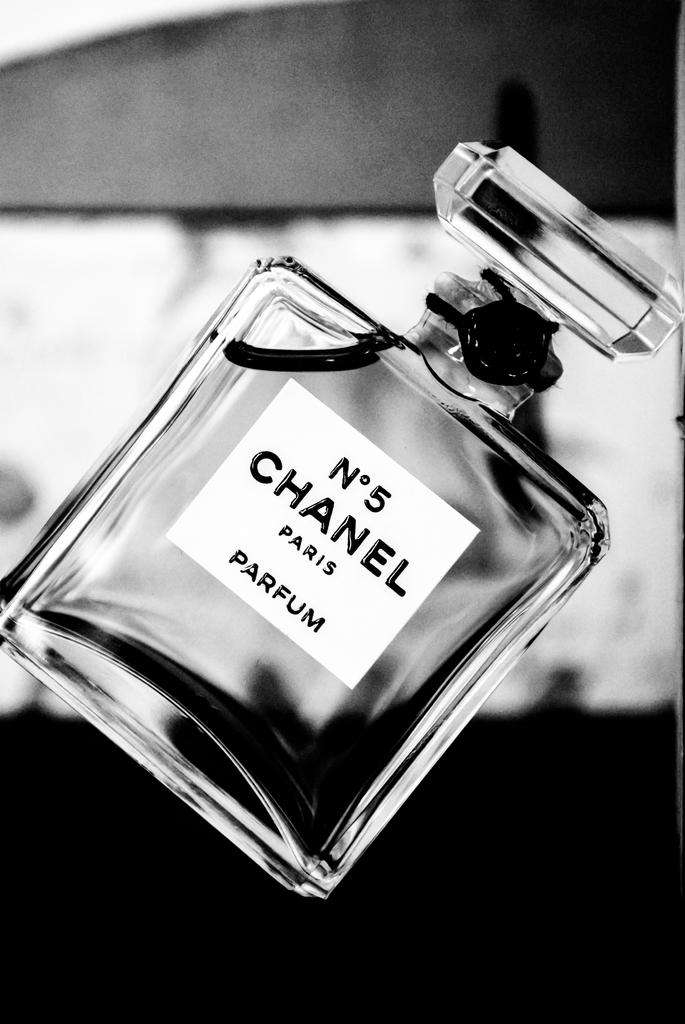<image>
Give a short and clear explanation of the subsequent image. A glass parfum bottle with the label No 5 Chanel Paris on it. 